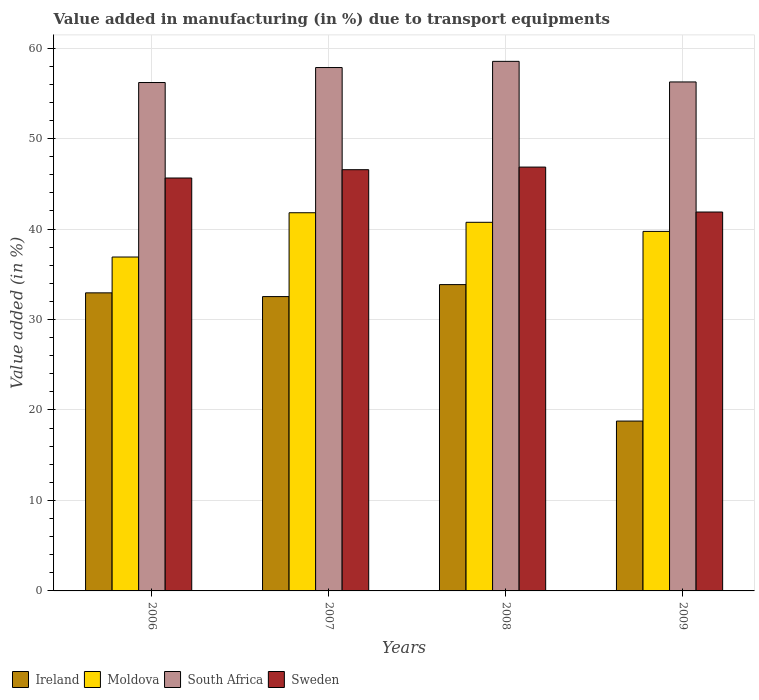How many groups of bars are there?
Offer a terse response. 4. Are the number of bars on each tick of the X-axis equal?
Give a very brief answer. Yes. How many bars are there on the 4th tick from the left?
Your answer should be compact. 4. What is the percentage of value added in manufacturing due to transport equipments in Sweden in 2007?
Keep it short and to the point. 46.56. Across all years, what is the maximum percentage of value added in manufacturing due to transport equipments in Ireland?
Provide a short and direct response. 33.86. Across all years, what is the minimum percentage of value added in manufacturing due to transport equipments in South Africa?
Offer a very short reply. 56.19. In which year was the percentage of value added in manufacturing due to transport equipments in Sweden minimum?
Keep it short and to the point. 2009. What is the total percentage of value added in manufacturing due to transport equipments in Moldova in the graph?
Make the answer very short. 159.18. What is the difference between the percentage of value added in manufacturing due to transport equipments in Ireland in 2006 and that in 2007?
Make the answer very short. 0.41. What is the difference between the percentage of value added in manufacturing due to transport equipments in Sweden in 2009 and the percentage of value added in manufacturing due to transport equipments in Ireland in 2006?
Make the answer very short. 8.93. What is the average percentage of value added in manufacturing due to transport equipments in Ireland per year?
Your response must be concise. 29.53. In the year 2009, what is the difference between the percentage of value added in manufacturing due to transport equipments in Moldova and percentage of value added in manufacturing due to transport equipments in South Africa?
Your response must be concise. -16.52. In how many years, is the percentage of value added in manufacturing due to transport equipments in Moldova greater than 48 %?
Provide a succinct answer. 0. What is the ratio of the percentage of value added in manufacturing due to transport equipments in South Africa in 2006 to that in 2007?
Offer a very short reply. 0.97. Is the percentage of value added in manufacturing due to transport equipments in South Africa in 2007 less than that in 2009?
Offer a terse response. No. What is the difference between the highest and the second highest percentage of value added in manufacturing due to transport equipments in Ireland?
Give a very brief answer. 0.91. What is the difference between the highest and the lowest percentage of value added in manufacturing due to transport equipments in South Africa?
Your answer should be very brief. 2.34. Is the sum of the percentage of value added in manufacturing due to transport equipments in South Africa in 2008 and 2009 greater than the maximum percentage of value added in manufacturing due to transport equipments in Moldova across all years?
Ensure brevity in your answer.  Yes. Is it the case that in every year, the sum of the percentage of value added in manufacturing due to transport equipments in Ireland and percentage of value added in manufacturing due to transport equipments in Sweden is greater than the sum of percentage of value added in manufacturing due to transport equipments in South Africa and percentage of value added in manufacturing due to transport equipments in Moldova?
Offer a terse response. No. What does the 4th bar from the left in 2006 represents?
Make the answer very short. Sweden. What does the 3rd bar from the right in 2006 represents?
Give a very brief answer. Moldova. Is it the case that in every year, the sum of the percentage of value added in manufacturing due to transport equipments in South Africa and percentage of value added in manufacturing due to transport equipments in Moldova is greater than the percentage of value added in manufacturing due to transport equipments in Sweden?
Give a very brief answer. Yes. How many bars are there?
Offer a very short reply. 16. Are all the bars in the graph horizontal?
Offer a very short reply. No. How many years are there in the graph?
Provide a succinct answer. 4. Are the values on the major ticks of Y-axis written in scientific E-notation?
Your answer should be compact. No. Does the graph contain any zero values?
Give a very brief answer. No. Does the graph contain grids?
Provide a succinct answer. Yes. What is the title of the graph?
Your answer should be very brief. Value added in manufacturing (in %) due to transport equipments. What is the label or title of the Y-axis?
Provide a succinct answer. Value added (in %). What is the Value added (in %) in Ireland in 2006?
Provide a succinct answer. 32.94. What is the Value added (in %) in Moldova in 2006?
Ensure brevity in your answer.  36.9. What is the Value added (in %) in South Africa in 2006?
Offer a terse response. 56.19. What is the Value added (in %) of Sweden in 2006?
Offer a terse response. 45.64. What is the Value added (in %) of Ireland in 2007?
Keep it short and to the point. 32.53. What is the Value added (in %) of Moldova in 2007?
Make the answer very short. 41.8. What is the Value added (in %) of South Africa in 2007?
Provide a succinct answer. 57.85. What is the Value added (in %) in Sweden in 2007?
Offer a terse response. 46.56. What is the Value added (in %) in Ireland in 2008?
Offer a very short reply. 33.86. What is the Value added (in %) of Moldova in 2008?
Provide a succinct answer. 40.74. What is the Value added (in %) of South Africa in 2008?
Your answer should be very brief. 58.53. What is the Value added (in %) in Sweden in 2008?
Keep it short and to the point. 46.84. What is the Value added (in %) in Ireland in 2009?
Provide a succinct answer. 18.77. What is the Value added (in %) in Moldova in 2009?
Make the answer very short. 39.74. What is the Value added (in %) in South Africa in 2009?
Give a very brief answer. 56.25. What is the Value added (in %) in Sweden in 2009?
Provide a short and direct response. 41.88. Across all years, what is the maximum Value added (in %) in Ireland?
Offer a terse response. 33.86. Across all years, what is the maximum Value added (in %) of Moldova?
Provide a short and direct response. 41.8. Across all years, what is the maximum Value added (in %) in South Africa?
Make the answer very short. 58.53. Across all years, what is the maximum Value added (in %) of Sweden?
Your answer should be compact. 46.84. Across all years, what is the minimum Value added (in %) in Ireland?
Ensure brevity in your answer.  18.77. Across all years, what is the minimum Value added (in %) of Moldova?
Your answer should be compact. 36.9. Across all years, what is the minimum Value added (in %) of South Africa?
Keep it short and to the point. 56.19. Across all years, what is the minimum Value added (in %) in Sweden?
Provide a short and direct response. 41.88. What is the total Value added (in %) of Ireland in the graph?
Offer a terse response. 118.1. What is the total Value added (in %) of Moldova in the graph?
Make the answer very short. 159.18. What is the total Value added (in %) in South Africa in the graph?
Offer a terse response. 228.82. What is the total Value added (in %) in Sweden in the graph?
Provide a succinct answer. 180.92. What is the difference between the Value added (in %) in Ireland in 2006 and that in 2007?
Your response must be concise. 0.41. What is the difference between the Value added (in %) of Moldova in 2006 and that in 2007?
Provide a short and direct response. -4.89. What is the difference between the Value added (in %) in South Africa in 2006 and that in 2007?
Offer a very short reply. -1.66. What is the difference between the Value added (in %) of Sweden in 2006 and that in 2007?
Offer a very short reply. -0.92. What is the difference between the Value added (in %) in Ireland in 2006 and that in 2008?
Give a very brief answer. -0.91. What is the difference between the Value added (in %) of Moldova in 2006 and that in 2008?
Your answer should be compact. -3.84. What is the difference between the Value added (in %) of South Africa in 2006 and that in 2008?
Offer a very short reply. -2.34. What is the difference between the Value added (in %) in Sweden in 2006 and that in 2008?
Your answer should be compact. -1.21. What is the difference between the Value added (in %) in Ireland in 2006 and that in 2009?
Ensure brevity in your answer.  14.17. What is the difference between the Value added (in %) of Moldova in 2006 and that in 2009?
Your answer should be very brief. -2.83. What is the difference between the Value added (in %) of South Africa in 2006 and that in 2009?
Your answer should be very brief. -0.06. What is the difference between the Value added (in %) of Sweden in 2006 and that in 2009?
Give a very brief answer. 3.76. What is the difference between the Value added (in %) in Ireland in 2007 and that in 2008?
Offer a very short reply. -1.32. What is the difference between the Value added (in %) of Moldova in 2007 and that in 2008?
Provide a short and direct response. 1.06. What is the difference between the Value added (in %) of South Africa in 2007 and that in 2008?
Your response must be concise. -0.68. What is the difference between the Value added (in %) in Sweden in 2007 and that in 2008?
Your answer should be compact. -0.29. What is the difference between the Value added (in %) of Ireland in 2007 and that in 2009?
Ensure brevity in your answer.  13.76. What is the difference between the Value added (in %) of Moldova in 2007 and that in 2009?
Ensure brevity in your answer.  2.06. What is the difference between the Value added (in %) of South Africa in 2007 and that in 2009?
Ensure brevity in your answer.  1.59. What is the difference between the Value added (in %) in Sweden in 2007 and that in 2009?
Make the answer very short. 4.68. What is the difference between the Value added (in %) of Ireland in 2008 and that in 2009?
Offer a very short reply. 15.08. What is the difference between the Value added (in %) of Moldova in 2008 and that in 2009?
Ensure brevity in your answer.  1.01. What is the difference between the Value added (in %) of South Africa in 2008 and that in 2009?
Offer a terse response. 2.28. What is the difference between the Value added (in %) of Sweden in 2008 and that in 2009?
Ensure brevity in your answer.  4.97. What is the difference between the Value added (in %) in Ireland in 2006 and the Value added (in %) in Moldova in 2007?
Ensure brevity in your answer.  -8.85. What is the difference between the Value added (in %) of Ireland in 2006 and the Value added (in %) of South Africa in 2007?
Ensure brevity in your answer.  -24.9. What is the difference between the Value added (in %) of Ireland in 2006 and the Value added (in %) of Sweden in 2007?
Give a very brief answer. -13.61. What is the difference between the Value added (in %) of Moldova in 2006 and the Value added (in %) of South Africa in 2007?
Make the answer very short. -20.94. What is the difference between the Value added (in %) of Moldova in 2006 and the Value added (in %) of Sweden in 2007?
Your answer should be very brief. -9.65. What is the difference between the Value added (in %) of South Africa in 2006 and the Value added (in %) of Sweden in 2007?
Your answer should be compact. 9.63. What is the difference between the Value added (in %) of Ireland in 2006 and the Value added (in %) of Moldova in 2008?
Offer a very short reply. -7.8. What is the difference between the Value added (in %) in Ireland in 2006 and the Value added (in %) in South Africa in 2008?
Offer a very short reply. -25.59. What is the difference between the Value added (in %) in Ireland in 2006 and the Value added (in %) in Sweden in 2008?
Your answer should be compact. -13.9. What is the difference between the Value added (in %) of Moldova in 2006 and the Value added (in %) of South Africa in 2008?
Your answer should be very brief. -21.63. What is the difference between the Value added (in %) in Moldova in 2006 and the Value added (in %) in Sweden in 2008?
Your answer should be compact. -9.94. What is the difference between the Value added (in %) of South Africa in 2006 and the Value added (in %) of Sweden in 2008?
Your response must be concise. 9.35. What is the difference between the Value added (in %) in Ireland in 2006 and the Value added (in %) in Moldova in 2009?
Provide a short and direct response. -6.79. What is the difference between the Value added (in %) of Ireland in 2006 and the Value added (in %) of South Africa in 2009?
Provide a short and direct response. -23.31. What is the difference between the Value added (in %) in Ireland in 2006 and the Value added (in %) in Sweden in 2009?
Provide a succinct answer. -8.93. What is the difference between the Value added (in %) of Moldova in 2006 and the Value added (in %) of South Africa in 2009?
Your response must be concise. -19.35. What is the difference between the Value added (in %) of Moldova in 2006 and the Value added (in %) of Sweden in 2009?
Provide a succinct answer. -4.97. What is the difference between the Value added (in %) in South Africa in 2006 and the Value added (in %) in Sweden in 2009?
Offer a very short reply. 14.31. What is the difference between the Value added (in %) of Ireland in 2007 and the Value added (in %) of Moldova in 2008?
Keep it short and to the point. -8.21. What is the difference between the Value added (in %) of Ireland in 2007 and the Value added (in %) of South Africa in 2008?
Provide a succinct answer. -26. What is the difference between the Value added (in %) in Ireland in 2007 and the Value added (in %) in Sweden in 2008?
Your answer should be compact. -14.31. What is the difference between the Value added (in %) in Moldova in 2007 and the Value added (in %) in South Africa in 2008?
Your response must be concise. -16.73. What is the difference between the Value added (in %) of Moldova in 2007 and the Value added (in %) of Sweden in 2008?
Your answer should be very brief. -5.05. What is the difference between the Value added (in %) in South Africa in 2007 and the Value added (in %) in Sweden in 2008?
Give a very brief answer. 11. What is the difference between the Value added (in %) in Ireland in 2007 and the Value added (in %) in Moldova in 2009?
Offer a very short reply. -7.2. What is the difference between the Value added (in %) in Ireland in 2007 and the Value added (in %) in South Africa in 2009?
Provide a succinct answer. -23.72. What is the difference between the Value added (in %) in Ireland in 2007 and the Value added (in %) in Sweden in 2009?
Offer a very short reply. -9.35. What is the difference between the Value added (in %) in Moldova in 2007 and the Value added (in %) in South Africa in 2009?
Make the answer very short. -14.46. What is the difference between the Value added (in %) in Moldova in 2007 and the Value added (in %) in Sweden in 2009?
Your answer should be very brief. -0.08. What is the difference between the Value added (in %) in South Africa in 2007 and the Value added (in %) in Sweden in 2009?
Your response must be concise. 15.97. What is the difference between the Value added (in %) of Ireland in 2008 and the Value added (in %) of Moldova in 2009?
Your response must be concise. -5.88. What is the difference between the Value added (in %) in Ireland in 2008 and the Value added (in %) in South Africa in 2009?
Your answer should be compact. -22.4. What is the difference between the Value added (in %) in Ireland in 2008 and the Value added (in %) in Sweden in 2009?
Give a very brief answer. -8.02. What is the difference between the Value added (in %) of Moldova in 2008 and the Value added (in %) of South Africa in 2009?
Your answer should be very brief. -15.51. What is the difference between the Value added (in %) in Moldova in 2008 and the Value added (in %) in Sweden in 2009?
Your response must be concise. -1.14. What is the difference between the Value added (in %) in South Africa in 2008 and the Value added (in %) in Sweden in 2009?
Give a very brief answer. 16.65. What is the average Value added (in %) in Ireland per year?
Your answer should be very brief. 29.53. What is the average Value added (in %) of Moldova per year?
Your answer should be compact. 39.79. What is the average Value added (in %) of South Africa per year?
Your answer should be very brief. 57.21. What is the average Value added (in %) in Sweden per year?
Provide a succinct answer. 45.23. In the year 2006, what is the difference between the Value added (in %) in Ireland and Value added (in %) in Moldova?
Offer a very short reply. -3.96. In the year 2006, what is the difference between the Value added (in %) of Ireland and Value added (in %) of South Africa?
Offer a terse response. -23.25. In the year 2006, what is the difference between the Value added (in %) of Ireland and Value added (in %) of Sweden?
Give a very brief answer. -12.69. In the year 2006, what is the difference between the Value added (in %) of Moldova and Value added (in %) of South Africa?
Give a very brief answer. -19.29. In the year 2006, what is the difference between the Value added (in %) of Moldova and Value added (in %) of Sweden?
Give a very brief answer. -8.73. In the year 2006, what is the difference between the Value added (in %) in South Africa and Value added (in %) in Sweden?
Your answer should be very brief. 10.55. In the year 2007, what is the difference between the Value added (in %) in Ireland and Value added (in %) in Moldova?
Provide a short and direct response. -9.27. In the year 2007, what is the difference between the Value added (in %) in Ireland and Value added (in %) in South Africa?
Give a very brief answer. -25.32. In the year 2007, what is the difference between the Value added (in %) of Ireland and Value added (in %) of Sweden?
Offer a very short reply. -14.02. In the year 2007, what is the difference between the Value added (in %) of Moldova and Value added (in %) of South Africa?
Ensure brevity in your answer.  -16.05. In the year 2007, what is the difference between the Value added (in %) in Moldova and Value added (in %) in Sweden?
Provide a succinct answer. -4.76. In the year 2007, what is the difference between the Value added (in %) of South Africa and Value added (in %) of Sweden?
Your answer should be compact. 11.29. In the year 2008, what is the difference between the Value added (in %) in Ireland and Value added (in %) in Moldova?
Offer a terse response. -6.89. In the year 2008, what is the difference between the Value added (in %) of Ireland and Value added (in %) of South Africa?
Offer a terse response. -24.67. In the year 2008, what is the difference between the Value added (in %) in Ireland and Value added (in %) in Sweden?
Provide a succinct answer. -12.99. In the year 2008, what is the difference between the Value added (in %) of Moldova and Value added (in %) of South Africa?
Provide a succinct answer. -17.79. In the year 2008, what is the difference between the Value added (in %) of Moldova and Value added (in %) of Sweden?
Keep it short and to the point. -6.1. In the year 2008, what is the difference between the Value added (in %) of South Africa and Value added (in %) of Sweden?
Your answer should be very brief. 11.69. In the year 2009, what is the difference between the Value added (in %) of Ireland and Value added (in %) of Moldova?
Ensure brevity in your answer.  -20.96. In the year 2009, what is the difference between the Value added (in %) of Ireland and Value added (in %) of South Africa?
Give a very brief answer. -37.48. In the year 2009, what is the difference between the Value added (in %) of Ireland and Value added (in %) of Sweden?
Offer a very short reply. -23.1. In the year 2009, what is the difference between the Value added (in %) in Moldova and Value added (in %) in South Africa?
Provide a short and direct response. -16.52. In the year 2009, what is the difference between the Value added (in %) of Moldova and Value added (in %) of Sweden?
Your response must be concise. -2.14. In the year 2009, what is the difference between the Value added (in %) in South Africa and Value added (in %) in Sweden?
Keep it short and to the point. 14.38. What is the ratio of the Value added (in %) in Ireland in 2006 to that in 2007?
Offer a terse response. 1.01. What is the ratio of the Value added (in %) of Moldova in 2006 to that in 2007?
Offer a very short reply. 0.88. What is the ratio of the Value added (in %) in South Africa in 2006 to that in 2007?
Ensure brevity in your answer.  0.97. What is the ratio of the Value added (in %) of Sweden in 2006 to that in 2007?
Keep it short and to the point. 0.98. What is the ratio of the Value added (in %) in Ireland in 2006 to that in 2008?
Provide a succinct answer. 0.97. What is the ratio of the Value added (in %) in Moldova in 2006 to that in 2008?
Your answer should be compact. 0.91. What is the ratio of the Value added (in %) of South Africa in 2006 to that in 2008?
Offer a terse response. 0.96. What is the ratio of the Value added (in %) of Sweden in 2006 to that in 2008?
Your answer should be very brief. 0.97. What is the ratio of the Value added (in %) in Ireland in 2006 to that in 2009?
Provide a succinct answer. 1.75. What is the ratio of the Value added (in %) of Moldova in 2006 to that in 2009?
Offer a very short reply. 0.93. What is the ratio of the Value added (in %) of Sweden in 2006 to that in 2009?
Offer a very short reply. 1.09. What is the ratio of the Value added (in %) of Ireland in 2007 to that in 2008?
Offer a very short reply. 0.96. What is the ratio of the Value added (in %) in Moldova in 2007 to that in 2008?
Ensure brevity in your answer.  1.03. What is the ratio of the Value added (in %) of South Africa in 2007 to that in 2008?
Give a very brief answer. 0.99. What is the ratio of the Value added (in %) of Ireland in 2007 to that in 2009?
Your answer should be compact. 1.73. What is the ratio of the Value added (in %) of Moldova in 2007 to that in 2009?
Offer a very short reply. 1.05. What is the ratio of the Value added (in %) of South Africa in 2007 to that in 2009?
Ensure brevity in your answer.  1.03. What is the ratio of the Value added (in %) in Sweden in 2007 to that in 2009?
Make the answer very short. 1.11. What is the ratio of the Value added (in %) in Ireland in 2008 to that in 2009?
Your answer should be compact. 1.8. What is the ratio of the Value added (in %) in Moldova in 2008 to that in 2009?
Provide a short and direct response. 1.03. What is the ratio of the Value added (in %) of South Africa in 2008 to that in 2009?
Provide a succinct answer. 1.04. What is the ratio of the Value added (in %) of Sweden in 2008 to that in 2009?
Provide a short and direct response. 1.12. What is the difference between the highest and the second highest Value added (in %) of Ireland?
Give a very brief answer. 0.91. What is the difference between the highest and the second highest Value added (in %) in Moldova?
Give a very brief answer. 1.06. What is the difference between the highest and the second highest Value added (in %) in South Africa?
Offer a very short reply. 0.68. What is the difference between the highest and the second highest Value added (in %) in Sweden?
Offer a very short reply. 0.29. What is the difference between the highest and the lowest Value added (in %) in Ireland?
Provide a succinct answer. 15.08. What is the difference between the highest and the lowest Value added (in %) of Moldova?
Offer a very short reply. 4.89. What is the difference between the highest and the lowest Value added (in %) in South Africa?
Offer a terse response. 2.34. What is the difference between the highest and the lowest Value added (in %) in Sweden?
Provide a succinct answer. 4.97. 